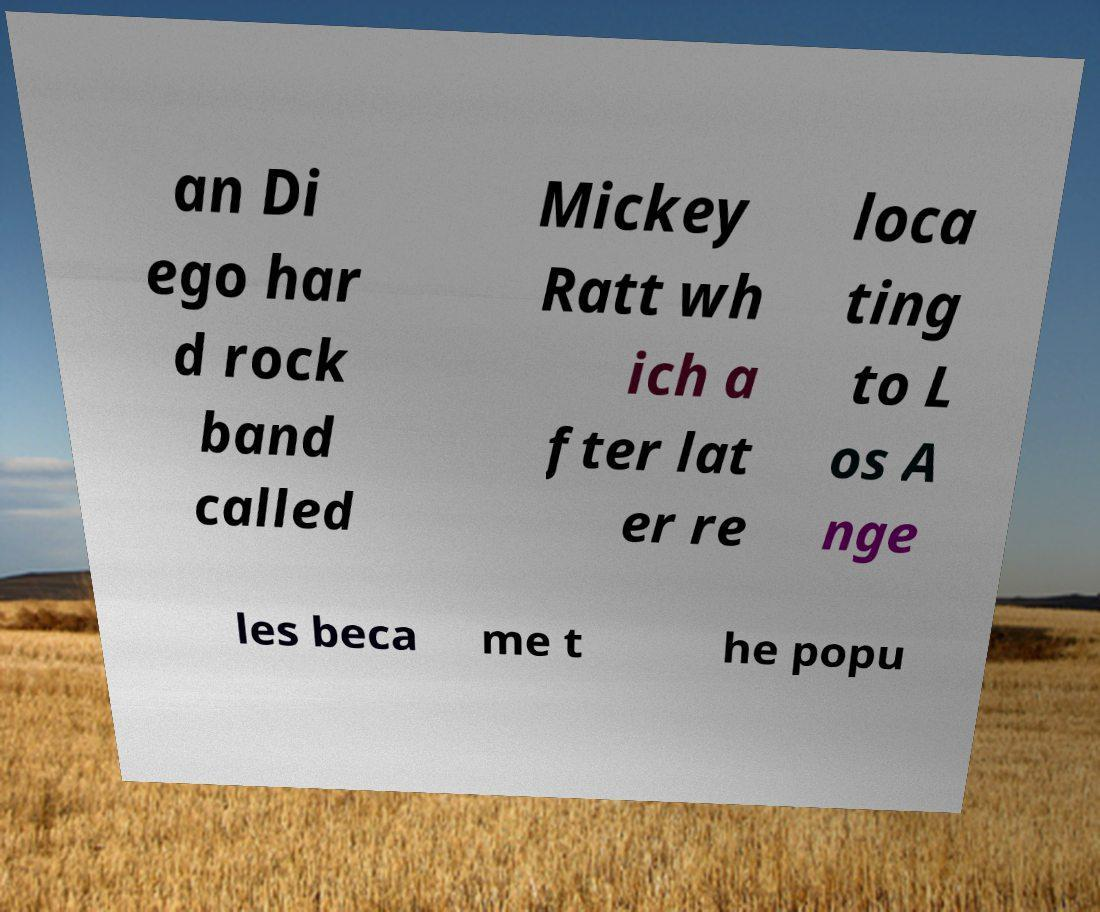Can you read and provide the text displayed in the image?This photo seems to have some interesting text. Can you extract and type it out for me? an Di ego har d rock band called Mickey Ratt wh ich a fter lat er re loca ting to L os A nge les beca me t he popu 